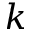Convert formula to latex. <formula><loc_0><loc_0><loc_500><loc_500>k</formula> 